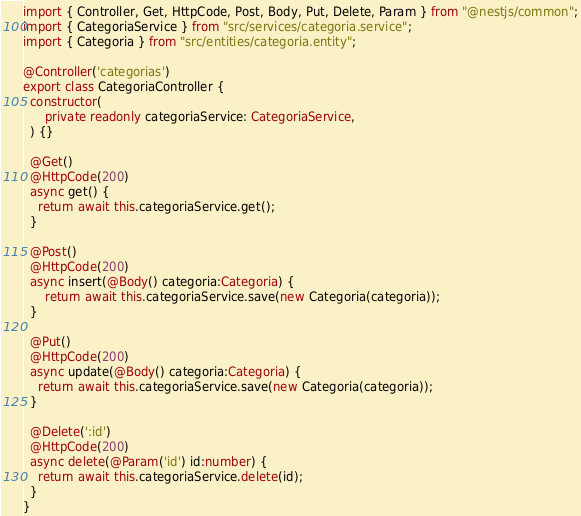Convert code to text. <code><loc_0><loc_0><loc_500><loc_500><_TypeScript_>import { Controller, Get, HttpCode, Post, Body, Put, Delete, Param } from "@nestjs/common";
import { CategoriaService } from "src/services/categoria.service";
import { Categoria } from "src/entities/categoria.entity";

@Controller('categorias')
export class CategoriaController {
  constructor(
      private readonly categoriaService: CategoriaService,
  ) {}

  @Get()
  @HttpCode(200)
  async get() {
    return await this.categoriaService.get();
  }

  @Post()
  @HttpCode(200)
  async insert(@Body() categoria:Categoria) {
      return await this.categoriaService.save(new Categoria(categoria));
  }

  @Put()
  @HttpCode(200)
  async update(@Body() categoria:Categoria) {
    return await this.categoriaService.save(new Categoria(categoria));
  }

  @Delete(':id')
  @HttpCode(200)
  async delete(@Param('id') id:number) {
    return await this.categoriaService.delete(id);
  }
}</code> 